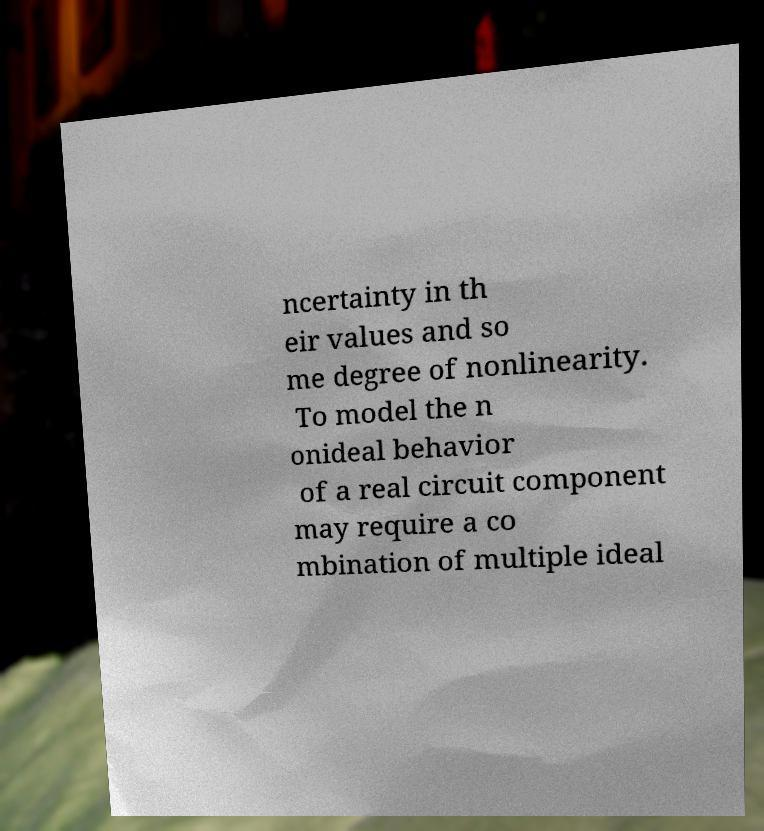For documentation purposes, I need the text within this image transcribed. Could you provide that? ncertainty in th eir values and so me degree of nonlinearity. To model the n onideal behavior of a real circuit component may require a co mbination of multiple ideal 